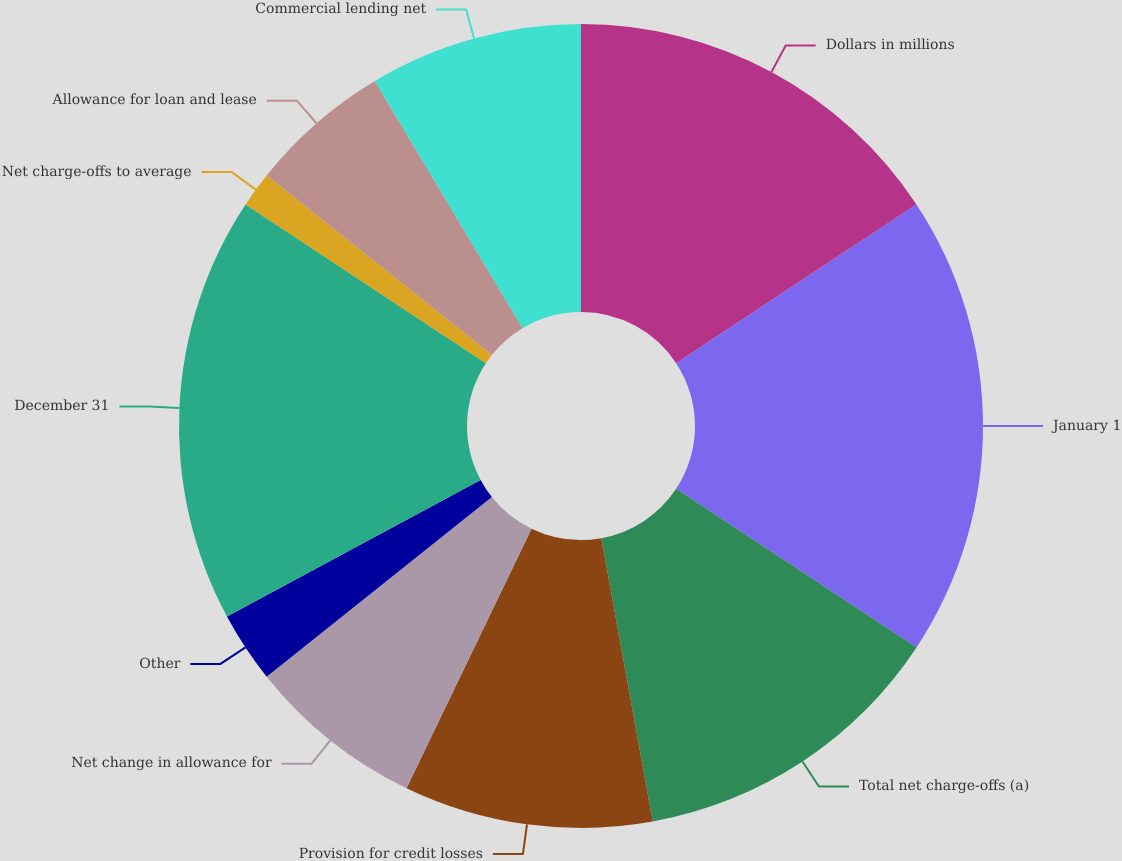<chart> <loc_0><loc_0><loc_500><loc_500><pie_chart><fcel>Dollars in millions<fcel>January 1<fcel>Total net charge-offs (a)<fcel>Provision for credit losses<fcel>Net change in allowance for<fcel>Other<fcel>December 31<fcel>Net charge-offs to average<fcel>Allowance for loan and lease<fcel>Commercial lending net<nl><fcel>15.71%<fcel>18.57%<fcel>12.86%<fcel>10.0%<fcel>7.14%<fcel>2.86%<fcel>17.14%<fcel>1.43%<fcel>5.71%<fcel>8.57%<nl></chart> 